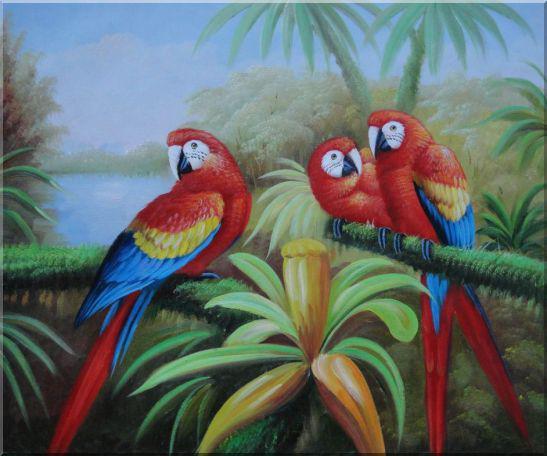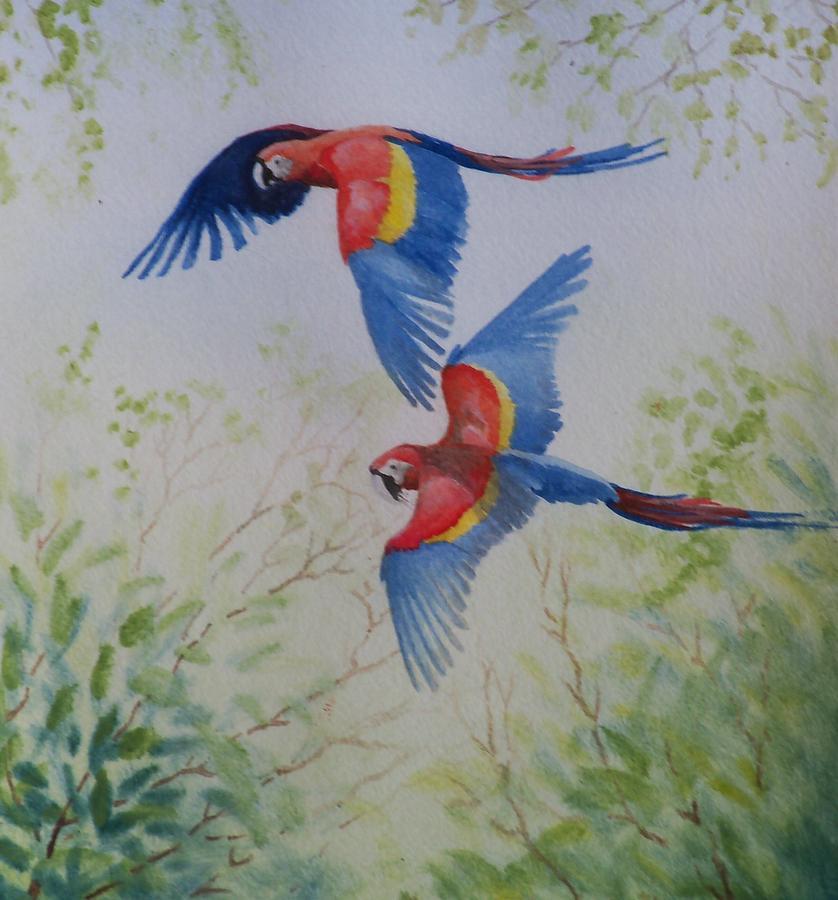The first image is the image on the left, the second image is the image on the right. Considering the images on both sides, is "An image includes two colorful parrots in flight." valid? Answer yes or no. Yes. 